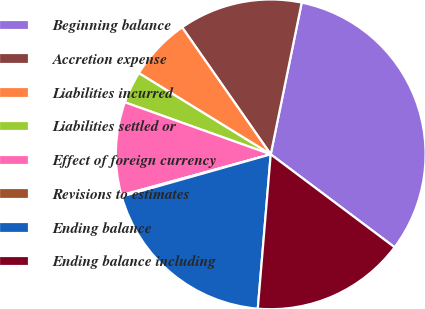Convert chart to OTSL. <chart><loc_0><loc_0><loc_500><loc_500><pie_chart><fcel>Beginning balance<fcel>Accretion expense<fcel>Liabilities incurred<fcel>Liabilities settled or<fcel>Effect of foreign currency<fcel>Revisions to estimates<fcel>Ending balance<fcel>Ending balance including<nl><fcel>32.04%<fcel>12.9%<fcel>6.52%<fcel>3.33%<fcel>9.71%<fcel>0.14%<fcel>19.28%<fcel>16.09%<nl></chart> 